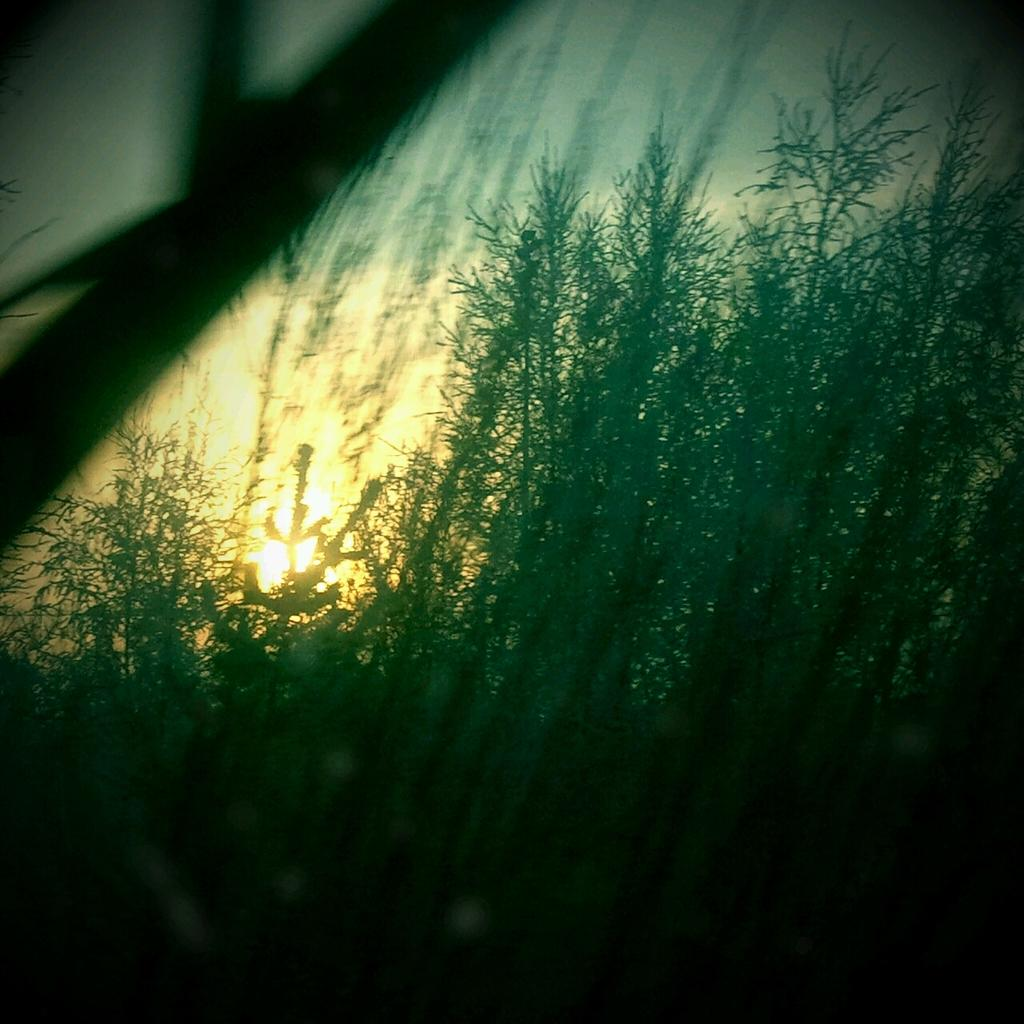What type of scene is depicted in the image? The image is a sunrise picture. What can be seen in the foreground of the image? There are many plants in the image. What is the position of the sun in the image? The sun is rising behind the plants. What type of leather material can be seen on the friend's jacket in the image? There is no friend or jacket present in the image; it is a sunrise scene with plants and the rising sun. 